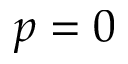<formula> <loc_0><loc_0><loc_500><loc_500>p = 0</formula> 